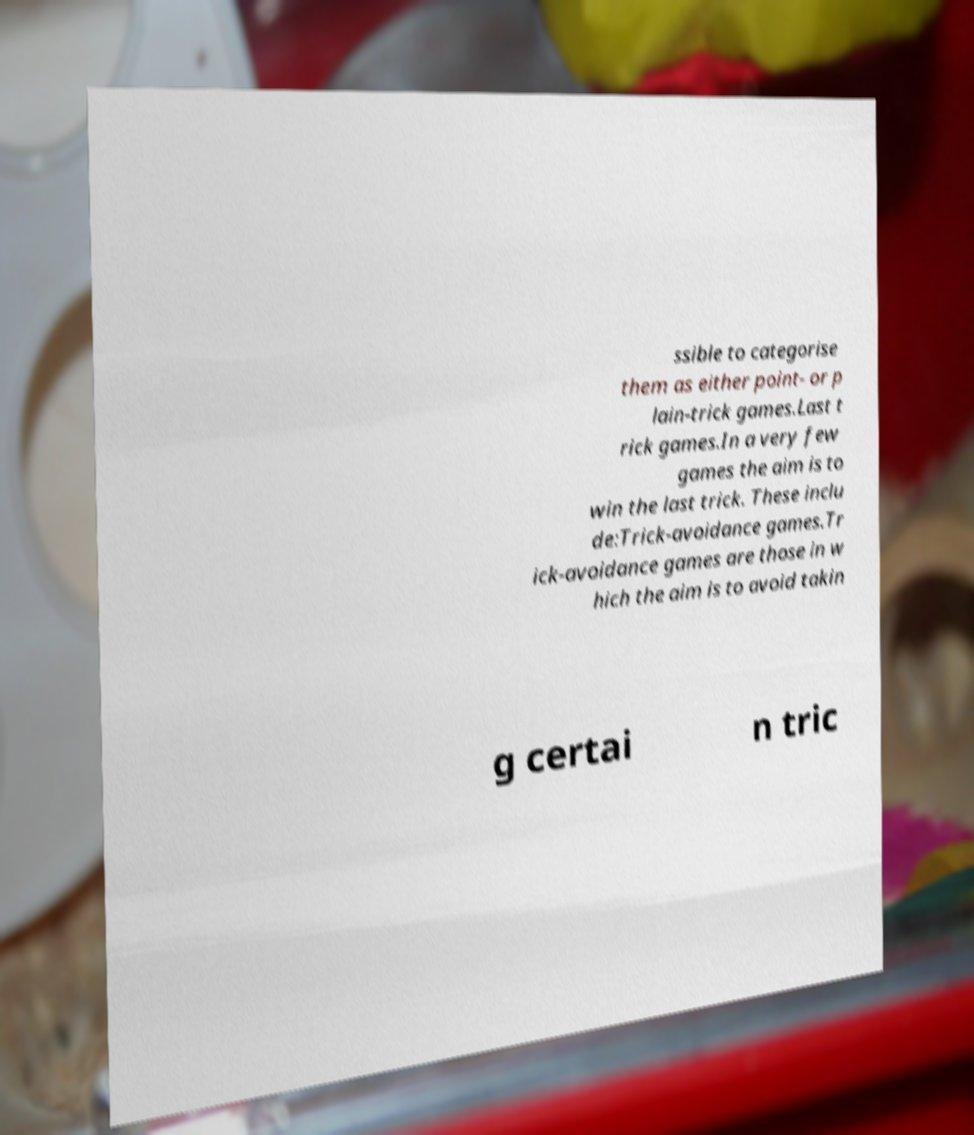What messages or text are displayed in this image? I need them in a readable, typed format. ssible to categorise them as either point- or p lain-trick games.Last t rick games.In a very few games the aim is to win the last trick. These inclu de:Trick-avoidance games.Tr ick-avoidance games are those in w hich the aim is to avoid takin g certai n tric 